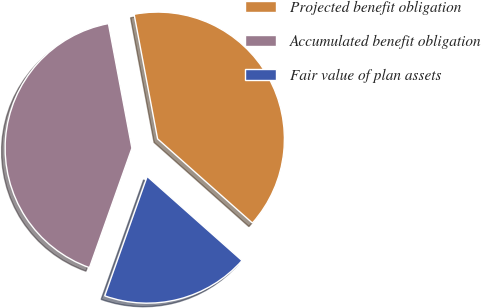Convert chart. <chart><loc_0><loc_0><loc_500><loc_500><pie_chart><fcel>Projected benefit obligation<fcel>Accumulated benefit obligation<fcel>Fair value of plan assets<nl><fcel>39.52%<fcel>41.6%<fcel>18.88%<nl></chart> 